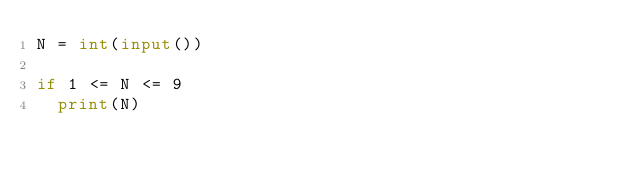Convert code to text. <code><loc_0><loc_0><loc_500><loc_500><_Python_>N = int(input())

if 1 <= N <= 9
	print(N)</code> 